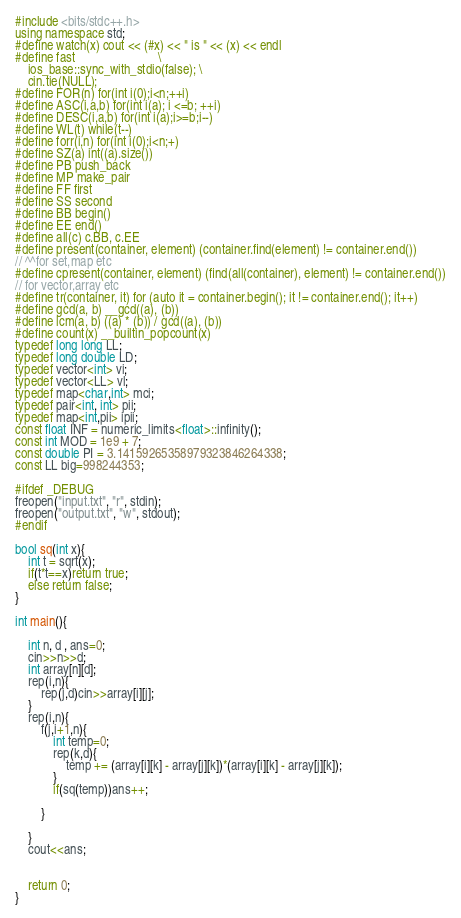Convert code to text. <code><loc_0><loc_0><loc_500><loc_500><_C++_>#include <bits/stdc++.h>
using namespace std;
#define watch(x) cout << (#x) << " is " << (x) << endl
#define fast                          \
	ios_base::sync_with_stdio(false); \
	cin.tie(NULL);
#define FOR(n) for(int i(0);i<n;++i)
#define ASC(i,a,b) for(int i(a); i <=b; ++i)
#define DESC(i,a,b) for(int i(a);i>=b;i--)
#define WL(t) while(t--)
#define forr(i,n) for(int i(0);i<n;+)
#define SZ(a) int((a).size())
#define PB push_back
#define MP make_pair
#define FF first
#define SS second
#define BB begin()
#define EE end()
#define all(c) c.BB, c.EE
#define present(container, element) (container.find(element) != container.end())
// ^^for set,map etc
#define cpresent(container, element) (find(all(container), element) != container.end())
// for vector,array etc
#define tr(container, it) for (auto it = container.begin(); it != container.end(); it++)
#define gcd(a, b) __gcd((a), (b))
#define lcm(a, b) ((a) * (b)) / gcd((a), (b))
#define count(x) __builtin_popcount(x) 
typedef long long LL;
typedef long double LD;
typedef vector<int> vi;
typedef vector<LL> vl;
typedef map<char,int> mci;
typedef pair<int, int> pii;
typedef map<int,pii> ipii;
const float INF = numeric_limits<float>::infinity();
const int MOD = 1e9 + 7;
const double PI = 3.14159265358979323846264338;
const LL big=998244353;
 
#ifdef _DEBUG
freopen("input.txt", "r", stdin);
freopen("output.txt", "w", stdout);
#endif
 
bool sq(int x){
	int t = sqrt(x);
	if(t*t==x)return true;
	else return false;
}

int main(){

	int n, d , ans=0;
	cin>>n>>d;
	int array[n][d];
	rep(i,n){
		rep(j,d)cin>>array[i][j];
	}
	rep(i,n){
		f(j,i+1,n){
			int temp=0;
			rep(k,d){
				temp += (array[i][k] - array[j][k])*(array[i][k] - array[j][k]);
			}
			if(sq(temp))ans++;

		}

	}
	cout<<ans;


	return 0;
}</code> 